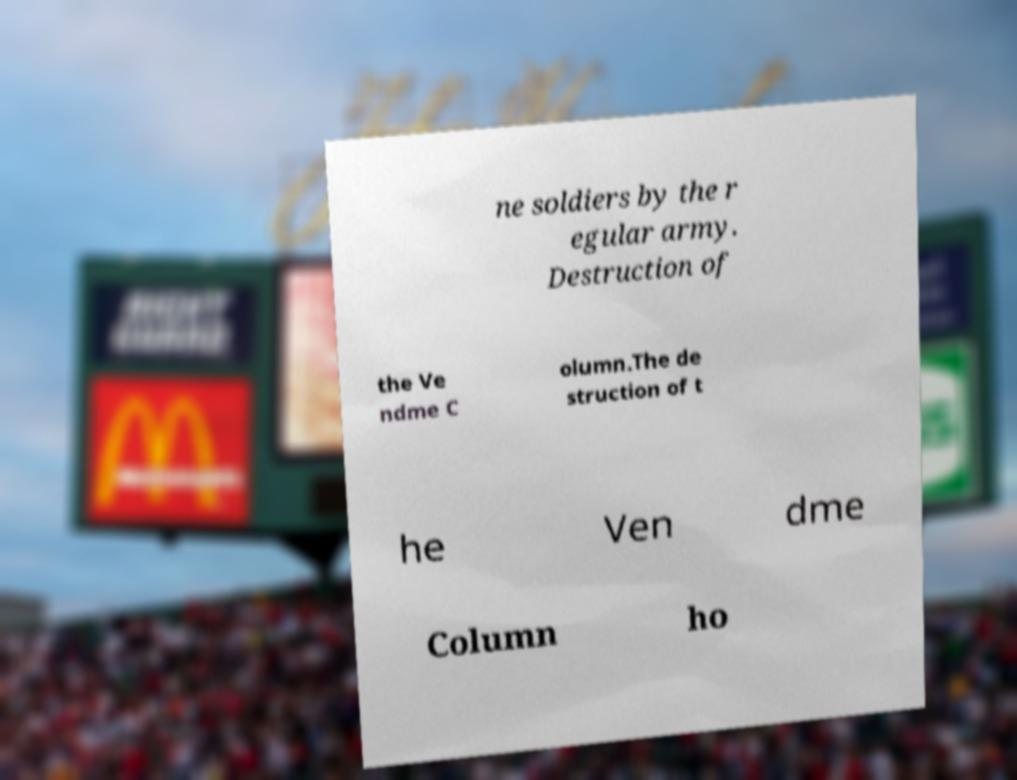Could you assist in decoding the text presented in this image and type it out clearly? ne soldiers by the r egular army. Destruction of the Ve ndme C olumn.The de struction of t he Ven dme Column ho 